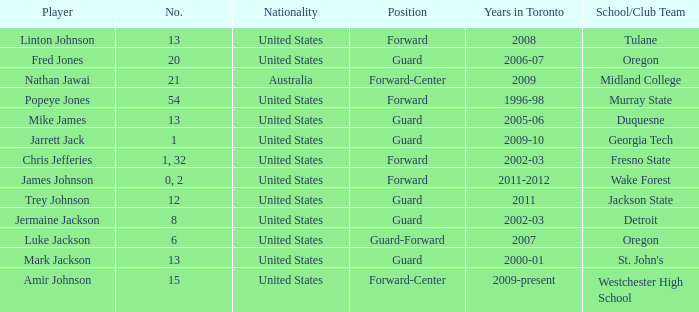What school/club team is Amir Johnson on? Westchester High School. 